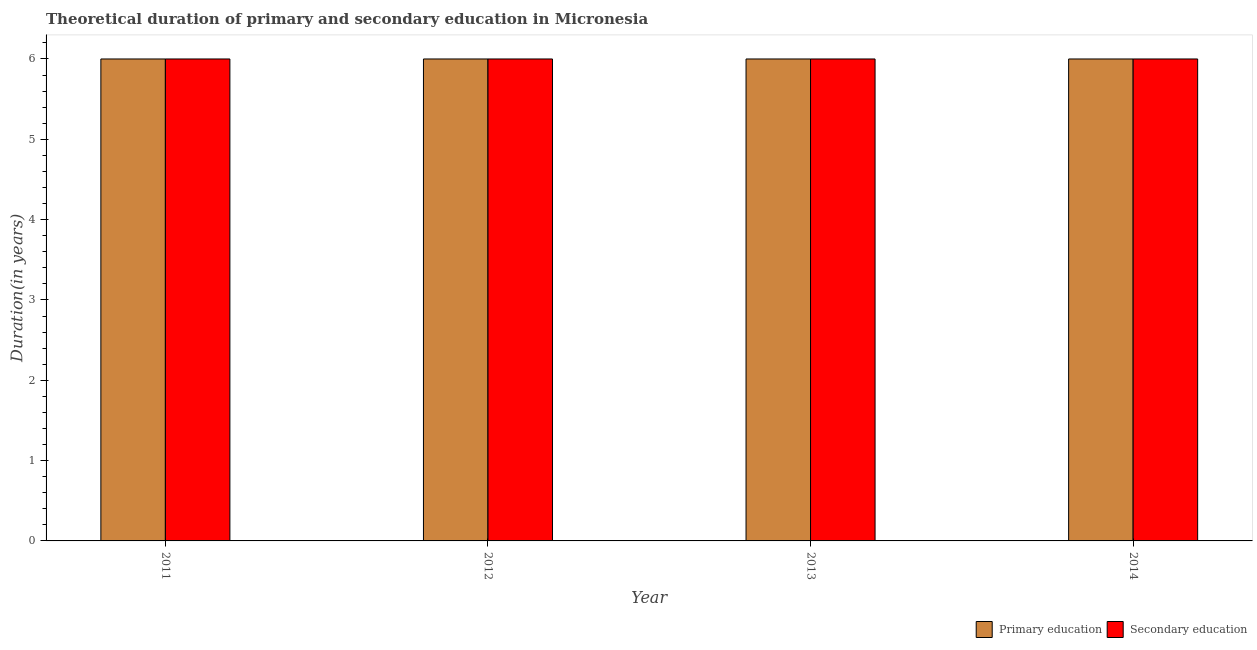How many different coloured bars are there?
Provide a short and direct response. 2. How many groups of bars are there?
Provide a short and direct response. 4. Are the number of bars on each tick of the X-axis equal?
Ensure brevity in your answer.  Yes. How many bars are there on the 1st tick from the left?
Your answer should be compact. 2. How many bars are there on the 2nd tick from the right?
Make the answer very short. 2. In how many cases, is the number of bars for a given year not equal to the number of legend labels?
Provide a short and direct response. 0. What is the duration of primary education in 2014?
Provide a succinct answer. 6. What is the total duration of secondary education in the graph?
Your answer should be very brief. 24. What is the difference between the duration of secondary education in 2011 and the duration of primary education in 2012?
Your answer should be very brief. 0. Is the duration of secondary education in 2011 less than that in 2014?
Your answer should be compact. No. Is the difference between the duration of primary education in 2013 and 2014 greater than the difference between the duration of secondary education in 2013 and 2014?
Ensure brevity in your answer.  No. What is the difference between the highest and the lowest duration of primary education?
Keep it short and to the point. 0. What does the 2nd bar from the left in 2013 represents?
Your answer should be very brief. Secondary education. What does the 1st bar from the right in 2012 represents?
Ensure brevity in your answer.  Secondary education. How many bars are there?
Your answer should be very brief. 8. How many years are there in the graph?
Provide a short and direct response. 4. Does the graph contain any zero values?
Provide a succinct answer. No. Does the graph contain grids?
Your response must be concise. No. How are the legend labels stacked?
Give a very brief answer. Horizontal. What is the title of the graph?
Your answer should be compact. Theoretical duration of primary and secondary education in Micronesia. What is the label or title of the Y-axis?
Offer a terse response. Duration(in years). What is the Duration(in years) in Secondary education in 2011?
Your answer should be very brief. 6. What is the Duration(in years) in Primary education in 2012?
Your answer should be compact. 6. What is the Duration(in years) of Secondary education in 2012?
Your answer should be very brief. 6. What is the Duration(in years) of Primary education in 2013?
Your answer should be compact. 6. What is the Duration(in years) in Primary education in 2014?
Offer a very short reply. 6. What is the Duration(in years) of Secondary education in 2014?
Your response must be concise. 6. Across all years, what is the maximum Duration(in years) of Secondary education?
Keep it short and to the point. 6. What is the total Duration(in years) in Primary education in the graph?
Ensure brevity in your answer.  24. What is the difference between the Duration(in years) in Secondary education in 2011 and that in 2012?
Give a very brief answer. 0. What is the difference between the Duration(in years) of Primary education in 2011 and that in 2013?
Provide a short and direct response. 0. What is the difference between the Duration(in years) of Secondary education in 2011 and that in 2013?
Your answer should be compact. 0. What is the difference between the Duration(in years) in Primary education in 2011 and that in 2014?
Your answer should be compact. 0. What is the difference between the Duration(in years) in Secondary education in 2012 and that in 2013?
Ensure brevity in your answer.  0. What is the difference between the Duration(in years) in Primary education in 2012 and that in 2014?
Provide a short and direct response. 0. What is the difference between the Duration(in years) of Secondary education in 2012 and that in 2014?
Offer a very short reply. 0. What is the difference between the Duration(in years) in Primary education in 2013 and that in 2014?
Provide a short and direct response. 0. What is the difference between the Duration(in years) of Primary education in 2011 and the Duration(in years) of Secondary education in 2012?
Offer a terse response. 0. What is the difference between the Duration(in years) of Primary education in 2011 and the Duration(in years) of Secondary education in 2013?
Your answer should be compact. 0. What is the difference between the Duration(in years) of Primary education in 2011 and the Duration(in years) of Secondary education in 2014?
Provide a succinct answer. 0. What is the difference between the Duration(in years) in Primary education in 2013 and the Duration(in years) in Secondary education in 2014?
Offer a terse response. 0. What is the average Duration(in years) of Primary education per year?
Offer a terse response. 6. In the year 2013, what is the difference between the Duration(in years) in Primary education and Duration(in years) in Secondary education?
Your answer should be very brief. 0. What is the ratio of the Duration(in years) in Primary education in 2011 to that in 2012?
Give a very brief answer. 1. What is the ratio of the Duration(in years) of Primary education in 2011 to that in 2013?
Give a very brief answer. 1. What is the ratio of the Duration(in years) of Secondary education in 2011 to that in 2013?
Ensure brevity in your answer.  1. What is the ratio of the Duration(in years) of Primary education in 2011 to that in 2014?
Provide a succinct answer. 1. What is the ratio of the Duration(in years) of Primary education in 2012 to that in 2013?
Your answer should be very brief. 1. What is the ratio of the Duration(in years) of Secondary education in 2012 to that in 2013?
Your answer should be very brief. 1. What is the ratio of the Duration(in years) in Primary education in 2012 to that in 2014?
Provide a short and direct response. 1. What is the ratio of the Duration(in years) in Secondary education in 2012 to that in 2014?
Give a very brief answer. 1. What is the ratio of the Duration(in years) of Primary education in 2013 to that in 2014?
Make the answer very short. 1. What is the ratio of the Duration(in years) in Secondary education in 2013 to that in 2014?
Keep it short and to the point. 1. What is the difference between the highest and the second highest Duration(in years) in Secondary education?
Your answer should be compact. 0. 